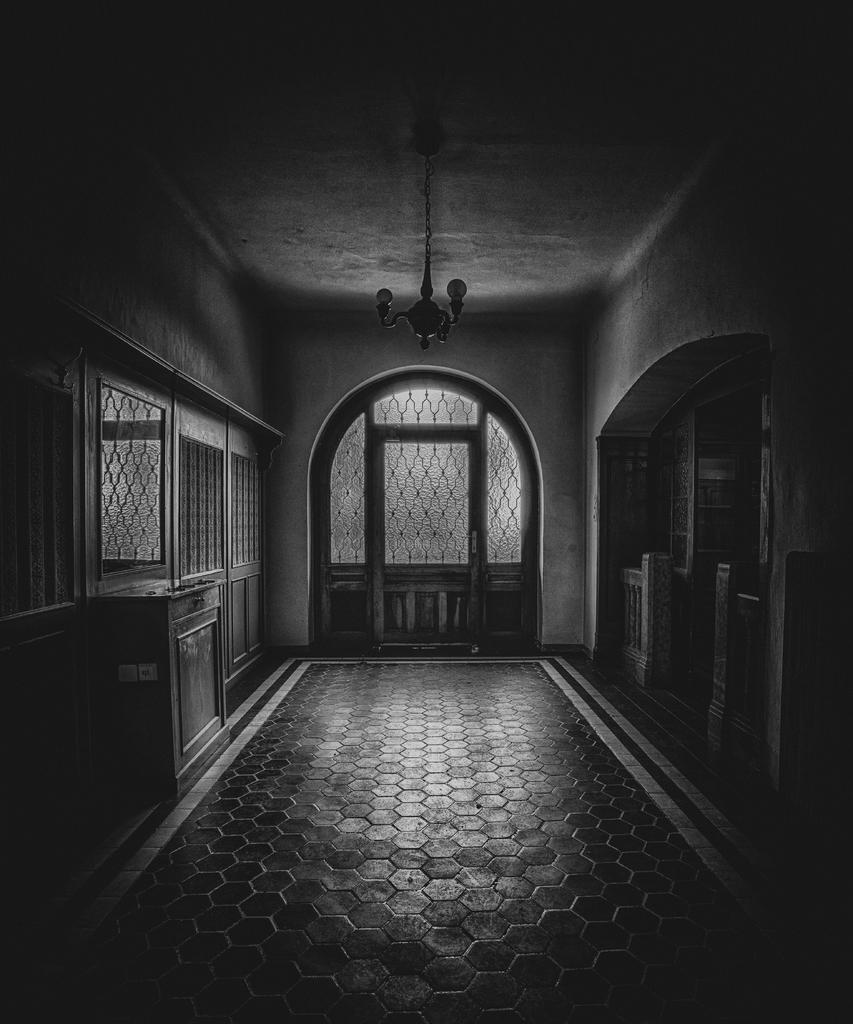What is the color scheme of the image? The image is in black and white. What architectural feature can be seen in the image? There is a door in the image. What other features are present in the image? There are windows and a wall in the image. What channel is being watched on the television in the image? There is no television present in the image; it only features a door, windows, and a wall. 